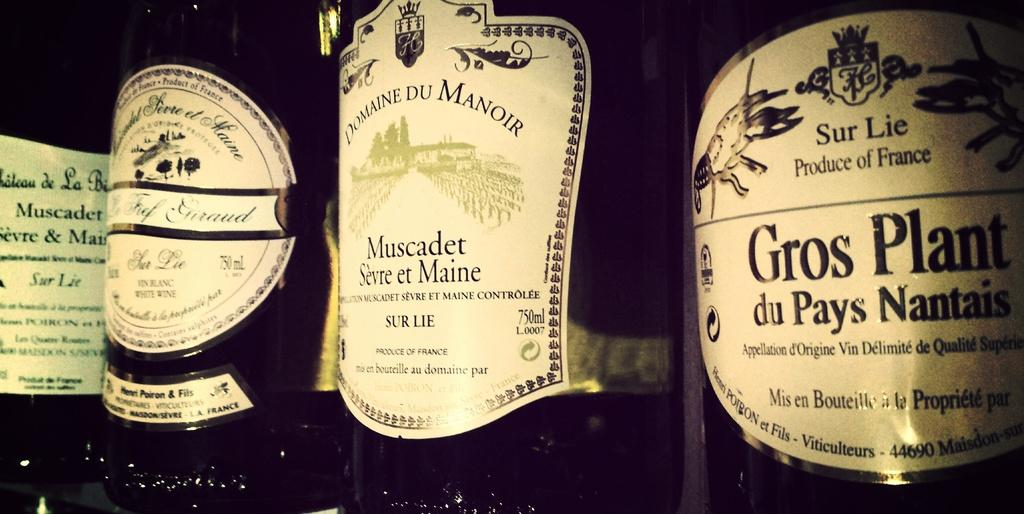<image>
Relay a brief, clear account of the picture shown. A bottle that is labeled as a product of France is to the right of several other bottles. 